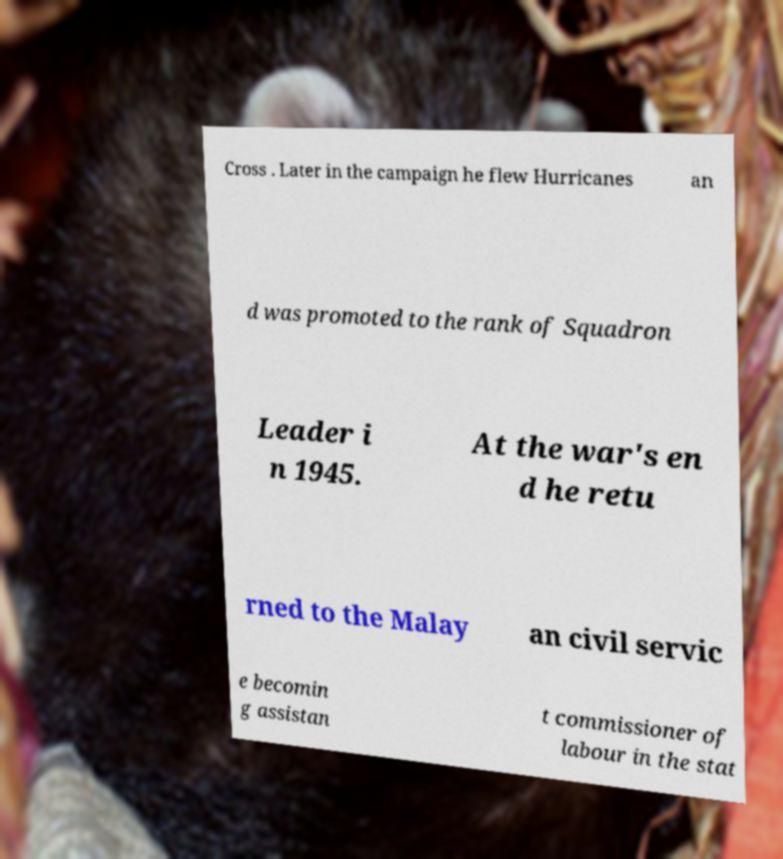I need the written content from this picture converted into text. Can you do that? Cross . Later in the campaign he flew Hurricanes an d was promoted to the rank of Squadron Leader i n 1945. At the war's en d he retu rned to the Malay an civil servic e becomin g assistan t commissioner of labour in the stat 